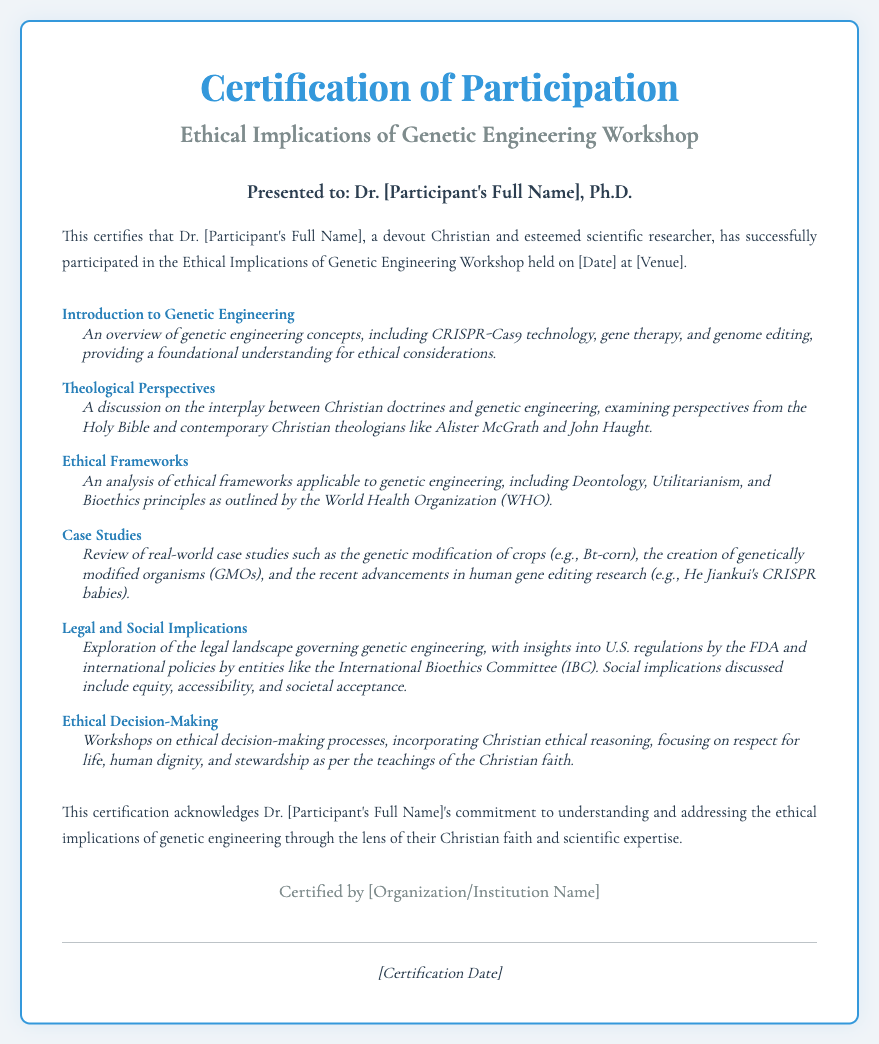What is the title of the workshop? The title is stated in the header section of the document.
Answer: Ethical Implications of Genetic Engineering Workshop Who presented the certificate? The certificate is presented in the section designated for that purpose.
Answer: Dr. [Participant's Full Name], Ph.D What is included in the outline of the workshop? The document specifies various topics discussed during the workshop.
Answer: Introduction to Genetic Engineering, Theological Perspectives, Ethical Frameworks, Case Studies, Legal and Social Implications, Ethical Decision-Making What does the introduction mention about the participant? The introduction highlights the participant's role and faith.
Answer: A devout Christian and esteemed scientific researcher When was the workshop held? The date is mentioned in the introduction of the certification.
Answer: [Date] Which organization certified the participation? The certifying organization is located in the footer of the document.
Answer: [Organization/Institution Name] What is a major ethical principle discussed in the workshop? The principles discussed relate to ethical decision-making in the context of genetic engineering.
Answer: Respect for life What technology is mentioned as an overview in the workshop? The overview of genetic engineering involves specific technologies discussed.
Answer: CRISPR-Cas9 technology Which body regulates genetic engineering in the U.S.? This is mentioned in the section discussing legal implications.
Answer: FDA 